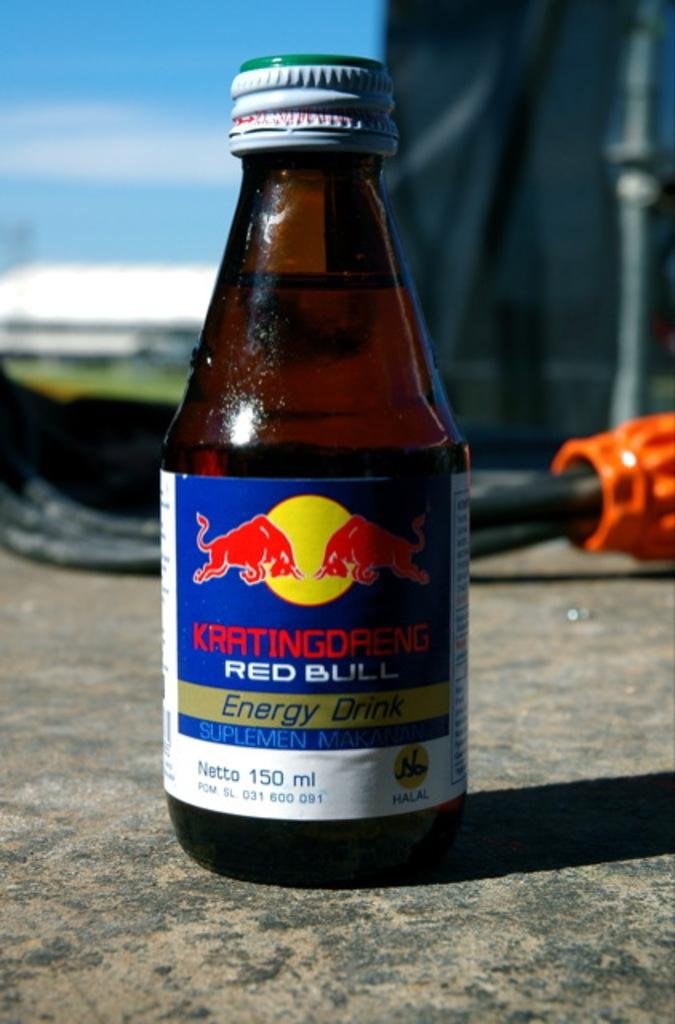Provide a one-sentence caption for the provided image. A little glass bottle of Red Bull Energy Drink placed on the ground outside. 